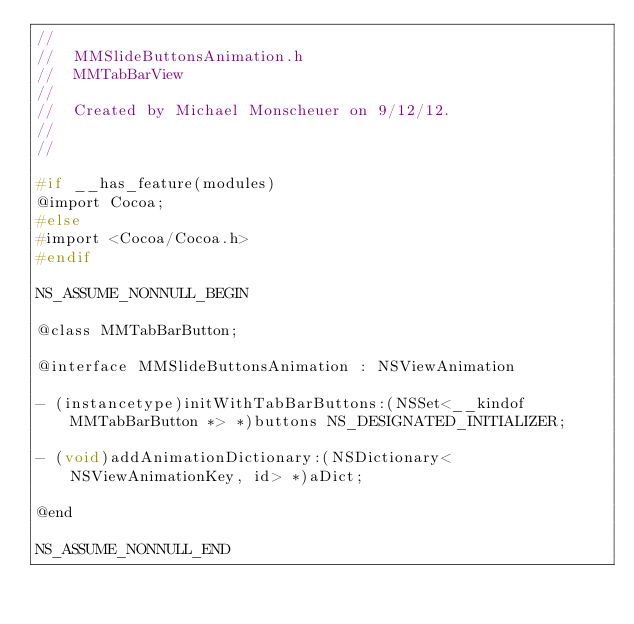<code> <loc_0><loc_0><loc_500><loc_500><_C_>//
//  MMSlideButtonsAnimation.h
//  MMTabBarView
//
//  Created by Michael Monscheuer on 9/12/12.
//
//

#if __has_feature(modules)
@import Cocoa;
#else
#import <Cocoa/Cocoa.h>
#endif

NS_ASSUME_NONNULL_BEGIN

@class MMTabBarButton;

@interface MMSlideButtonsAnimation : NSViewAnimation

- (instancetype)initWithTabBarButtons:(NSSet<__kindof MMTabBarButton *> *)buttons NS_DESIGNATED_INITIALIZER;

- (void)addAnimationDictionary:(NSDictionary<NSViewAnimationKey, id> *)aDict;

@end

NS_ASSUME_NONNULL_END
</code> 